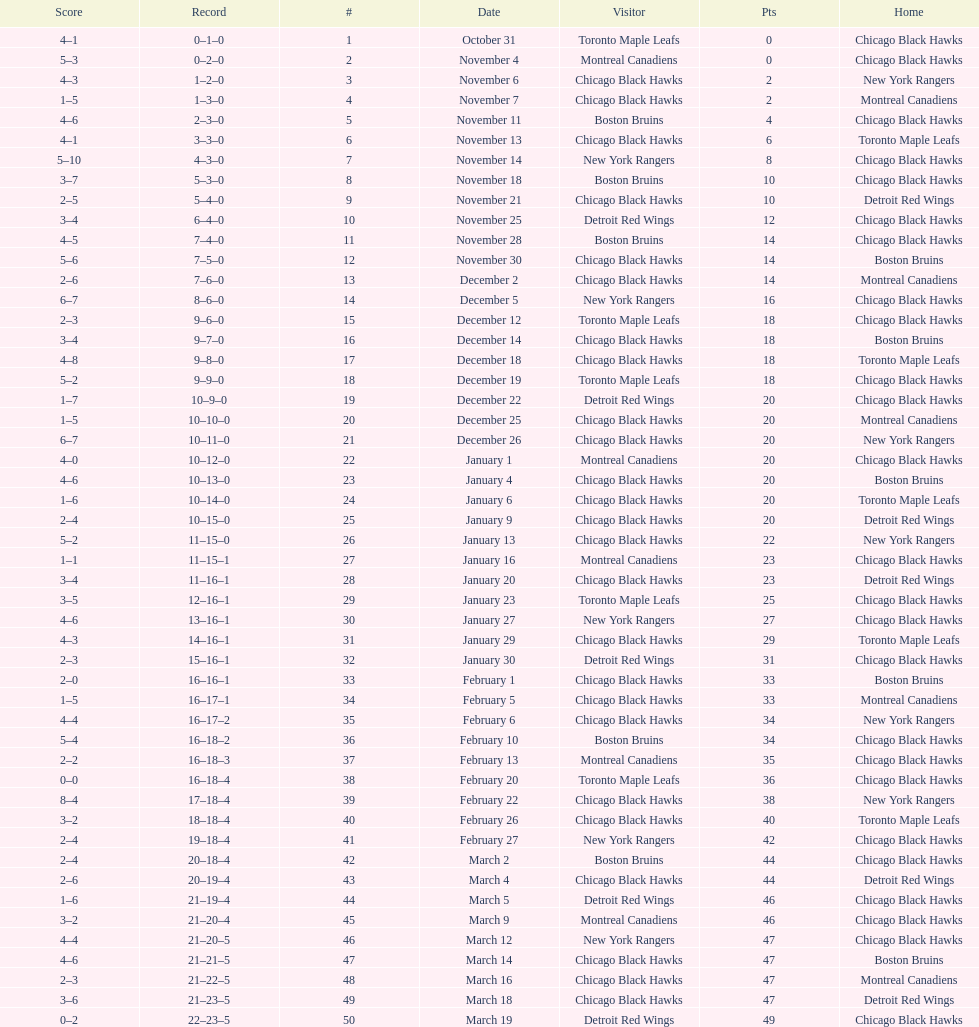Could you parse the entire table? {'header': ['Score', 'Record', '#', 'Date', 'Visitor', 'Pts', 'Home'], 'rows': [['4–1', '0–1–0', '1', 'October 31', 'Toronto Maple Leafs', '0', 'Chicago Black Hawks'], ['5–3', '0–2–0', '2', 'November 4', 'Montreal Canadiens', '0', 'Chicago Black Hawks'], ['4–3', '1–2–0', '3', 'November 6', 'Chicago Black Hawks', '2', 'New York Rangers'], ['1–5', '1–3–0', '4', 'November 7', 'Chicago Black Hawks', '2', 'Montreal Canadiens'], ['4–6', '2–3–0', '5', 'November 11', 'Boston Bruins', '4', 'Chicago Black Hawks'], ['4–1', '3–3–0', '6', 'November 13', 'Chicago Black Hawks', '6', 'Toronto Maple Leafs'], ['5–10', '4–3–0', '7', 'November 14', 'New York Rangers', '8', 'Chicago Black Hawks'], ['3–7', '5–3–0', '8', 'November 18', 'Boston Bruins', '10', 'Chicago Black Hawks'], ['2–5', '5–4–0', '9', 'November 21', 'Chicago Black Hawks', '10', 'Detroit Red Wings'], ['3–4', '6–4–0', '10', 'November 25', 'Detroit Red Wings', '12', 'Chicago Black Hawks'], ['4–5', '7–4–0', '11', 'November 28', 'Boston Bruins', '14', 'Chicago Black Hawks'], ['5–6', '7–5–0', '12', 'November 30', 'Chicago Black Hawks', '14', 'Boston Bruins'], ['2–6', '7–6–0', '13', 'December 2', 'Chicago Black Hawks', '14', 'Montreal Canadiens'], ['6–7', '8–6–0', '14', 'December 5', 'New York Rangers', '16', 'Chicago Black Hawks'], ['2–3', '9–6–0', '15', 'December 12', 'Toronto Maple Leafs', '18', 'Chicago Black Hawks'], ['3–4', '9–7–0', '16', 'December 14', 'Chicago Black Hawks', '18', 'Boston Bruins'], ['4–8', '9–8–0', '17', 'December 18', 'Chicago Black Hawks', '18', 'Toronto Maple Leafs'], ['5–2', '9–9–0', '18', 'December 19', 'Toronto Maple Leafs', '18', 'Chicago Black Hawks'], ['1–7', '10–9–0', '19', 'December 22', 'Detroit Red Wings', '20', 'Chicago Black Hawks'], ['1–5', '10–10–0', '20', 'December 25', 'Chicago Black Hawks', '20', 'Montreal Canadiens'], ['6–7', '10–11–0', '21', 'December 26', 'Chicago Black Hawks', '20', 'New York Rangers'], ['4–0', '10–12–0', '22', 'January 1', 'Montreal Canadiens', '20', 'Chicago Black Hawks'], ['4–6', '10–13–0', '23', 'January 4', 'Chicago Black Hawks', '20', 'Boston Bruins'], ['1–6', '10–14–0', '24', 'January 6', 'Chicago Black Hawks', '20', 'Toronto Maple Leafs'], ['2–4', '10–15–0', '25', 'January 9', 'Chicago Black Hawks', '20', 'Detroit Red Wings'], ['5–2', '11–15–0', '26', 'January 13', 'Chicago Black Hawks', '22', 'New York Rangers'], ['1–1', '11–15–1', '27', 'January 16', 'Montreal Canadiens', '23', 'Chicago Black Hawks'], ['3–4', '11–16–1', '28', 'January 20', 'Chicago Black Hawks', '23', 'Detroit Red Wings'], ['3–5', '12–16–1', '29', 'January 23', 'Toronto Maple Leafs', '25', 'Chicago Black Hawks'], ['4–6', '13–16–1', '30', 'January 27', 'New York Rangers', '27', 'Chicago Black Hawks'], ['4–3', '14–16–1', '31', 'January 29', 'Chicago Black Hawks', '29', 'Toronto Maple Leafs'], ['2–3', '15–16–1', '32', 'January 30', 'Detroit Red Wings', '31', 'Chicago Black Hawks'], ['2–0', '16–16–1', '33', 'February 1', 'Chicago Black Hawks', '33', 'Boston Bruins'], ['1–5', '16–17–1', '34', 'February 5', 'Chicago Black Hawks', '33', 'Montreal Canadiens'], ['4–4', '16–17–2', '35', 'February 6', 'Chicago Black Hawks', '34', 'New York Rangers'], ['5–4', '16–18–2', '36', 'February 10', 'Boston Bruins', '34', 'Chicago Black Hawks'], ['2–2', '16–18–3', '37', 'February 13', 'Montreal Canadiens', '35', 'Chicago Black Hawks'], ['0–0', '16–18–4', '38', 'February 20', 'Toronto Maple Leafs', '36', 'Chicago Black Hawks'], ['8–4', '17–18–4', '39', 'February 22', 'Chicago Black Hawks', '38', 'New York Rangers'], ['3–2', '18–18–4', '40', 'February 26', 'Chicago Black Hawks', '40', 'Toronto Maple Leafs'], ['2–4', '19–18–4', '41', 'February 27', 'New York Rangers', '42', 'Chicago Black Hawks'], ['2–4', '20–18–4', '42', 'March 2', 'Boston Bruins', '44', 'Chicago Black Hawks'], ['2–6', '20–19–4', '43', 'March 4', 'Chicago Black Hawks', '44', 'Detroit Red Wings'], ['1–6', '21–19–4', '44', 'March 5', 'Detroit Red Wings', '46', 'Chicago Black Hawks'], ['3–2', '21–20–4', '45', 'March 9', 'Montreal Canadiens', '46', 'Chicago Black Hawks'], ['4–4', '21–20–5', '46', 'March 12', 'New York Rangers', '47', 'Chicago Black Hawks'], ['4–6', '21–21–5', '47', 'March 14', 'Chicago Black Hawks', '47', 'Boston Bruins'], ['2–3', '21–22–5', '48', 'March 16', 'Chicago Black Hawks', '47', 'Montreal Canadiens'], ['3–6', '21–23–5', '49', 'March 18', 'Chicago Black Hawks', '47', 'Detroit Red Wings'], ['0–2', '22–23–5', '50', 'March 19', 'Detroit Red Wings', '49', 'Chicago Black Hawks']]} How many total games did they win? 22. 